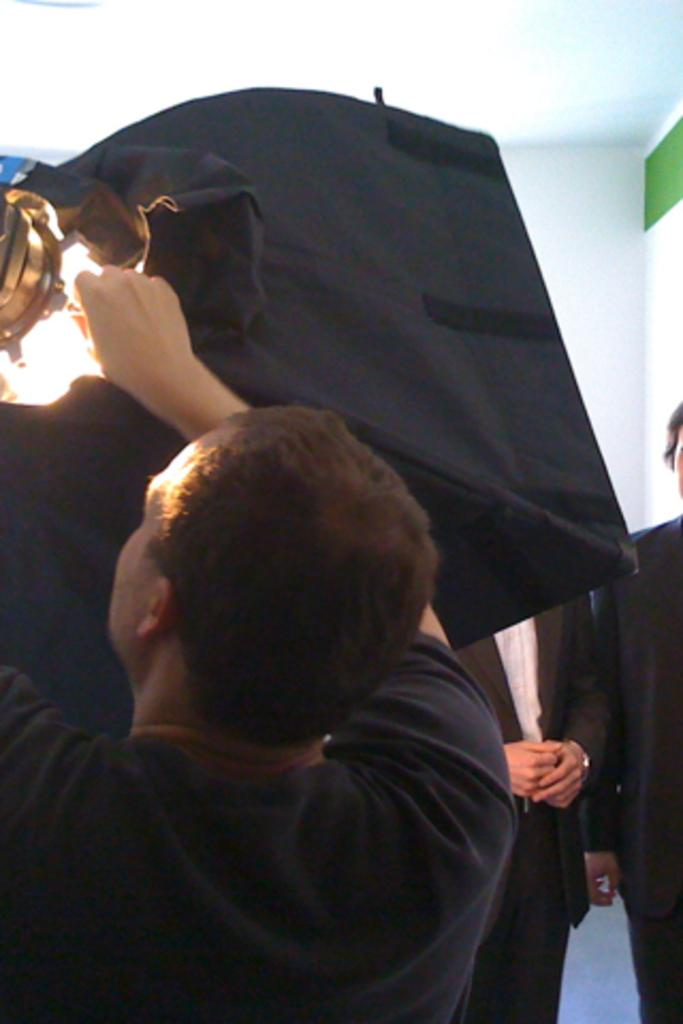How many men are in the image? There are men in the image, but the exact number is not specified. What is the man in the foreground holding? The man in the foreground is holding an object. What can be seen in the top right corner of the image? There is a light in the top right corner of the image. What part of the room is visible at the top of the image? The ceiling is visible at the top of the image. What type of cord is connected to the sugar in the image? There is no cord or sugar present in the image. 